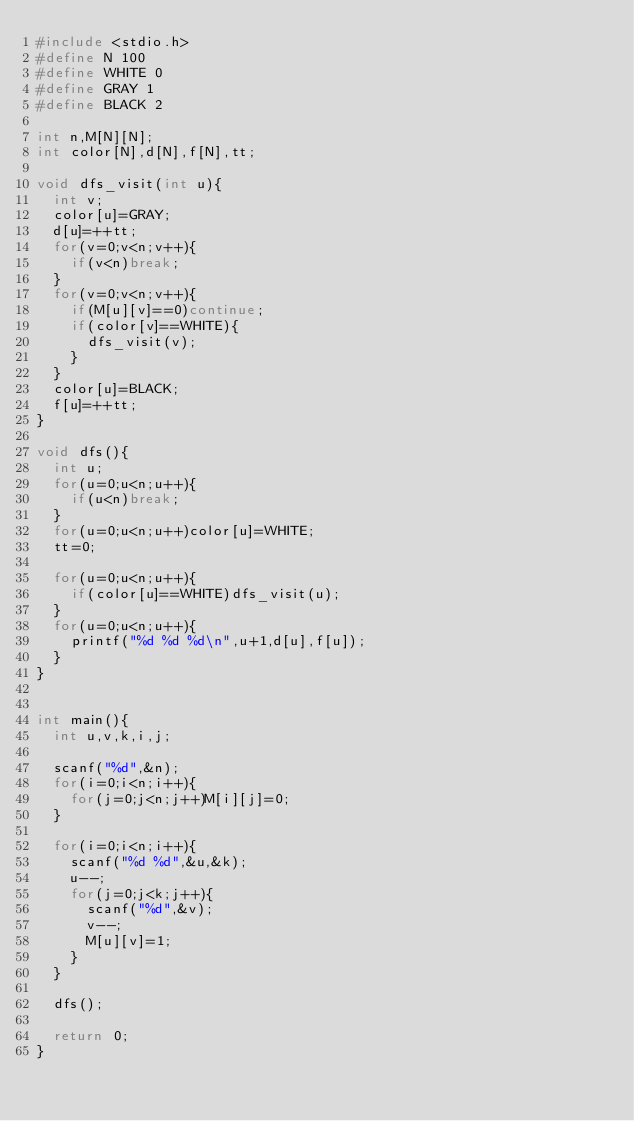Convert code to text. <code><loc_0><loc_0><loc_500><loc_500><_C_>#include <stdio.h>
#define N 100
#define WHITE 0
#define GRAY 1
#define BLACK 2

int n,M[N][N];
int color[N],d[N],f[N],tt;

void dfs_visit(int u){
  int v;
  color[u]=GRAY;
  d[u]=++tt;
  for(v=0;v<n;v++){
    if(v<n)break;
  }
  for(v=0;v<n;v++){
    if(M[u][v]==0)continue;
    if(color[v]==WHITE){
      dfs_visit(v);
    }
  }
  color[u]=BLACK;
  f[u]=++tt;
}

void dfs(){
  int u;
  for(u=0;u<n;u++){
    if(u<n)break;
  }
  for(u=0;u<n;u++)color[u]=WHITE;
  tt=0;

  for(u=0;u<n;u++){
    if(color[u]==WHITE)dfs_visit(u);
  }
  for(u=0;u<n;u++){
    printf("%d %d %d\n",u+1,d[u],f[u]);
  }
}


int main(){
  int u,v,k,i,j;

  scanf("%d",&n);
  for(i=0;i<n;i++){
    for(j=0;j<n;j++)M[i][j]=0;
  }

  for(i=0;i<n;i++){
    scanf("%d %d",&u,&k);
    u--;
    for(j=0;j<k;j++){
      scanf("%d",&v);
      v--;
      M[u][v]=1;
    }
  }

  dfs();

  return 0;
}
  

</code> 